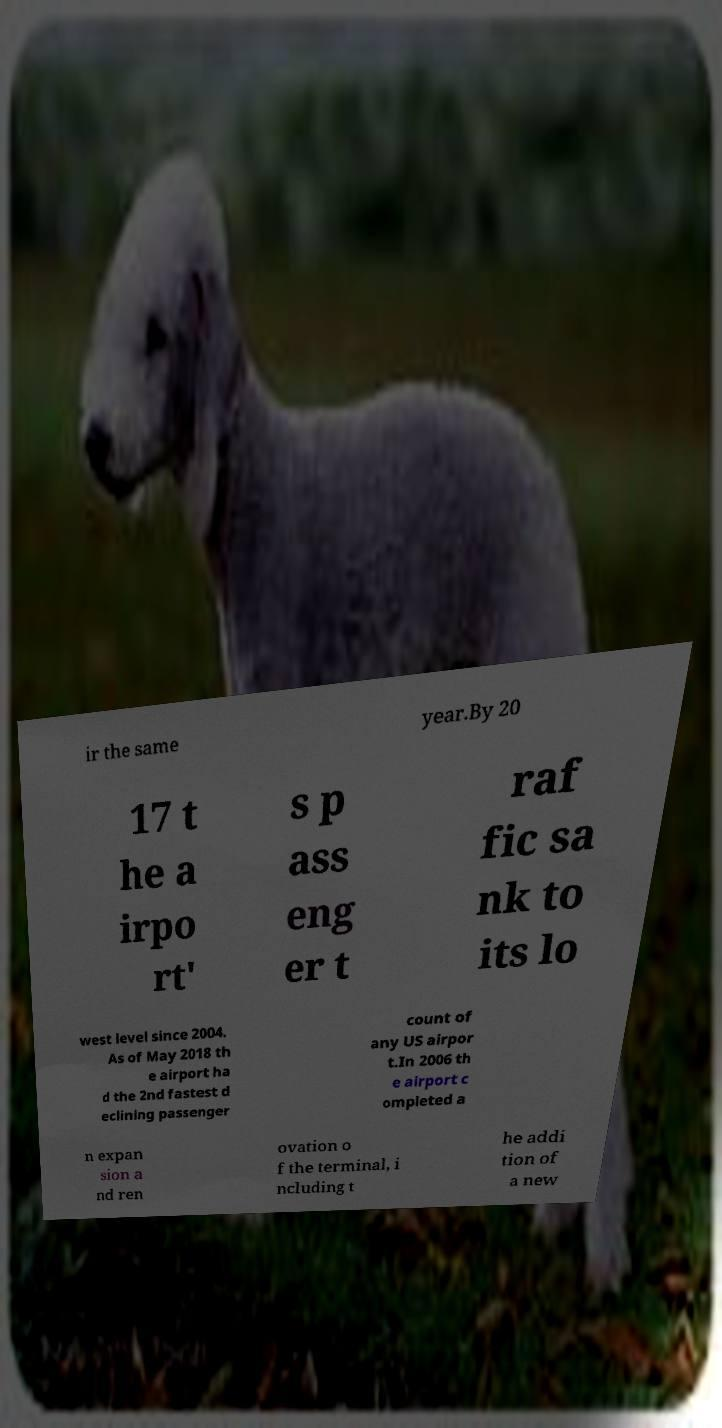I need the written content from this picture converted into text. Can you do that? ir the same year.By 20 17 t he a irpo rt' s p ass eng er t raf fic sa nk to its lo west level since 2004. As of May 2018 th e airport ha d the 2nd fastest d eclining passenger count of any US airpor t.In 2006 th e airport c ompleted a n expan sion a nd ren ovation o f the terminal, i ncluding t he addi tion of a new 